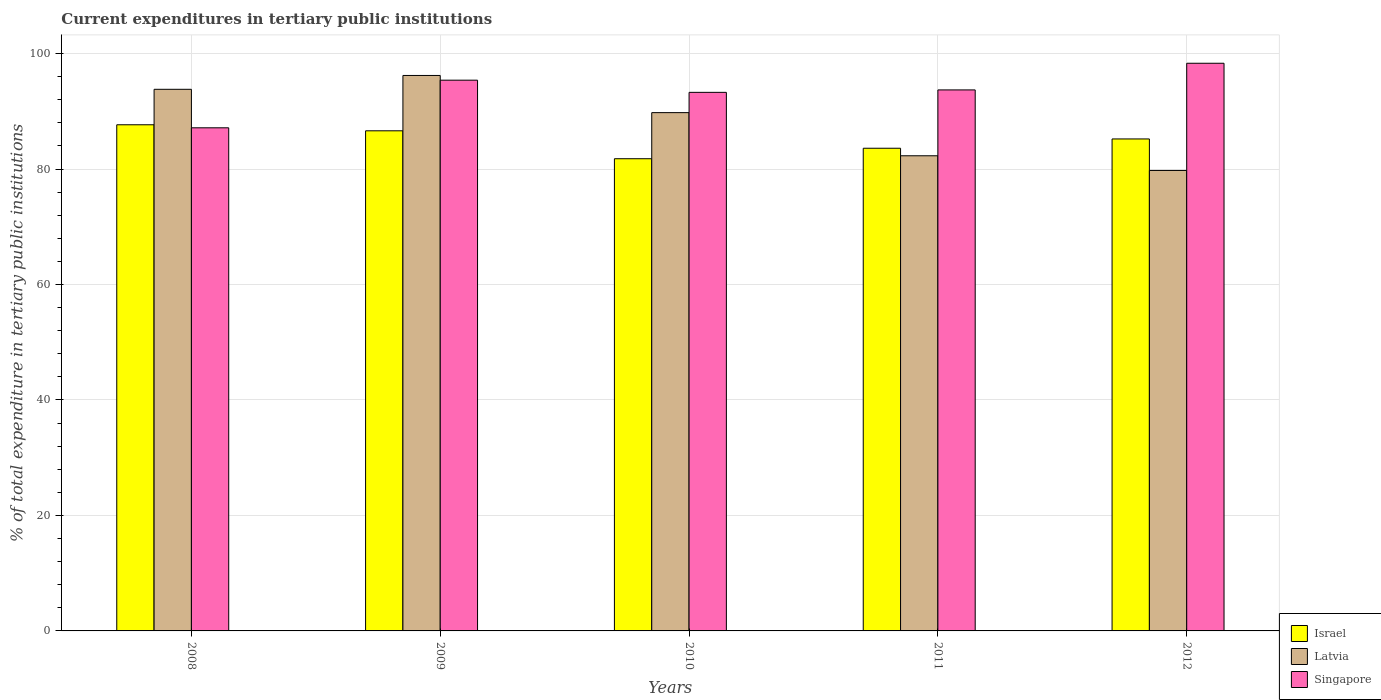How many different coloured bars are there?
Make the answer very short. 3. Are the number of bars per tick equal to the number of legend labels?
Offer a terse response. Yes. How many bars are there on the 2nd tick from the left?
Offer a terse response. 3. What is the label of the 2nd group of bars from the left?
Offer a very short reply. 2009. What is the current expenditures in tertiary public institutions in Latvia in 2010?
Your response must be concise. 89.77. Across all years, what is the maximum current expenditures in tertiary public institutions in Israel?
Ensure brevity in your answer.  87.67. Across all years, what is the minimum current expenditures in tertiary public institutions in Israel?
Your answer should be compact. 81.78. What is the total current expenditures in tertiary public institutions in Israel in the graph?
Ensure brevity in your answer.  424.89. What is the difference between the current expenditures in tertiary public institutions in Singapore in 2008 and that in 2011?
Give a very brief answer. -6.56. What is the difference between the current expenditures in tertiary public institutions in Israel in 2011 and the current expenditures in tertiary public institutions in Singapore in 2012?
Make the answer very short. -14.72. What is the average current expenditures in tertiary public institutions in Latvia per year?
Ensure brevity in your answer.  88.37. In the year 2009, what is the difference between the current expenditures in tertiary public institutions in Latvia and current expenditures in tertiary public institutions in Israel?
Offer a terse response. 9.58. In how many years, is the current expenditures in tertiary public institutions in Latvia greater than 68 %?
Ensure brevity in your answer.  5. What is the ratio of the current expenditures in tertiary public institutions in Singapore in 2009 to that in 2012?
Keep it short and to the point. 0.97. Is the difference between the current expenditures in tertiary public institutions in Latvia in 2008 and 2011 greater than the difference between the current expenditures in tertiary public institutions in Israel in 2008 and 2011?
Your answer should be very brief. Yes. What is the difference between the highest and the second highest current expenditures in tertiary public institutions in Latvia?
Provide a short and direct response. 2.4. What is the difference between the highest and the lowest current expenditures in tertiary public institutions in Singapore?
Offer a terse response. 11.18. In how many years, is the current expenditures in tertiary public institutions in Israel greater than the average current expenditures in tertiary public institutions in Israel taken over all years?
Your response must be concise. 3. Is the sum of the current expenditures in tertiary public institutions in Latvia in 2008 and 2009 greater than the maximum current expenditures in tertiary public institutions in Singapore across all years?
Give a very brief answer. Yes. What does the 2nd bar from the left in 2012 represents?
Offer a terse response. Latvia. What does the 2nd bar from the right in 2008 represents?
Your answer should be compact. Latvia. Is it the case that in every year, the sum of the current expenditures in tertiary public institutions in Israel and current expenditures in tertiary public institutions in Latvia is greater than the current expenditures in tertiary public institutions in Singapore?
Offer a terse response. Yes. How many years are there in the graph?
Your answer should be very brief. 5. What is the difference between two consecutive major ticks on the Y-axis?
Provide a succinct answer. 20. Are the values on the major ticks of Y-axis written in scientific E-notation?
Keep it short and to the point. No. How many legend labels are there?
Keep it short and to the point. 3. What is the title of the graph?
Ensure brevity in your answer.  Current expenditures in tertiary public institutions. What is the label or title of the Y-axis?
Your answer should be very brief. % of total expenditure in tertiary public institutions. What is the % of total expenditure in tertiary public institutions in Israel in 2008?
Your response must be concise. 87.67. What is the % of total expenditure in tertiary public institutions of Latvia in 2008?
Provide a short and direct response. 93.81. What is the % of total expenditure in tertiary public institutions of Singapore in 2008?
Ensure brevity in your answer.  87.14. What is the % of total expenditure in tertiary public institutions of Israel in 2009?
Offer a terse response. 86.62. What is the % of total expenditure in tertiary public institutions of Latvia in 2009?
Your answer should be very brief. 96.21. What is the % of total expenditure in tertiary public institutions in Singapore in 2009?
Ensure brevity in your answer.  95.39. What is the % of total expenditure in tertiary public institutions of Israel in 2010?
Your answer should be very brief. 81.78. What is the % of total expenditure in tertiary public institutions of Latvia in 2010?
Provide a short and direct response. 89.77. What is the % of total expenditure in tertiary public institutions in Singapore in 2010?
Ensure brevity in your answer.  93.28. What is the % of total expenditure in tertiary public institutions of Israel in 2011?
Give a very brief answer. 83.6. What is the % of total expenditure in tertiary public institutions of Latvia in 2011?
Provide a succinct answer. 82.3. What is the % of total expenditure in tertiary public institutions in Singapore in 2011?
Give a very brief answer. 93.7. What is the % of total expenditure in tertiary public institutions in Israel in 2012?
Your answer should be very brief. 85.21. What is the % of total expenditure in tertiary public institutions in Latvia in 2012?
Give a very brief answer. 79.75. What is the % of total expenditure in tertiary public institutions in Singapore in 2012?
Your response must be concise. 98.32. Across all years, what is the maximum % of total expenditure in tertiary public institutions of Israel?
Offer a very short reply. 87.67. Across all years, what is the maximum % of total expenditure in tertiary public institutions in Latvia?
Make the answer very short. 96.21. Across all years, what is the maximum % of total expenditure in tertiary public institutions of Singapore?
Make the answer very short. 98.32. Across all years, what is the minimum % of total expenditure in tertiary public institutions in Israel?
Give a very brief answer. 81.78. Across all years, what is the minimum % of total expenditure in tertiary public institutions in Latvia?
Provide a succinct answer. 79.75. Across all years, what is the minimum % of total expenditure in tertiary public institutions of Singapore?
Give a very brief answer. 87.14. What is the total % of total expenditure in tertiary public institutions of Israel in the graph?
Keep it short and to the point. 424.89. What is the total % of total expenditure in tertiary public institutions of Latvia in the graph?
Your response must be concise. 441.83. What is the total % of total expenditure in tertiary public institutions of Singapore in the graph?
Give a very brief answer. 467.84. What is the difference between the % of total expenditure in tertiary public institutions of Israel in 2008 and that in 2009?
Keep it short and to the point. 1.04. What is the difference between the % of total expenditure in tertiary public institutions in Latvia in 2008 and that in 2009?
Your answer should be compact. -2.4. What is the difference between the % of total expenditure in tertiary public institutions in Singapore in 2008 and that in 2009?
Offer a terse response. -8.25. What is the difference between the % of total expenditure in tertiary public institutions of Israel in 2008 and that in 2010?
Provide a short and direct response. 5.88. What is the difference between the % of total expenditure in tertiary public institutions of Latvia in 2008 and that in 2010?
Provide a succinct answer. 4.04. What is the difference between the % of total expenditure in tertiary public institutions in Singapore in 2008 and that in 2010?
Your answer should be compact. -6.14. What is the difference between the % of total expenditure in tertiary public institutions of Israel in 2008 and that in 2011?
Your response must be concise. 4.07. What is the difference between the % of total expenditure in tertiary public institutions of Latvia in 2008 and that in 2011?
Offer a very short reply. 11.51. What is the difference between the % of total expenditure in tertiary public institutions of Singapore in 2008 and that in 2011?
Keep it short and to the point. -6.56. What is the difference between the % of total expenditure in tertiary public institutions of Israel in 2008 and that in 2012?
Your answer should be compact. 2.46. What is the difference between the % of total expenditure in tertiary public institutions of Latvia in 2008 and that in 2012?
Give a very brief answer. 14.06. What is the difference between the % of total expenditure in tertiary public institutions in Singapore in 2008 and that in 2012?
Ensure brevity in your answer.  -11.18. What is the difference between the % of total expenditure in tertiary public institutions of Israel in 2009 and that in 2010?
Provide a succinct answer. 4.84. What is the difference between the % of total expenditure in tertiary public institutions in Latvia in 2009 and that in 2010?
Offer a terse response. 6.44. What is the difference between the % of total expenditure in tertiary public institutions in Singapore in 2009 and that in 2010?
Offer a terse response. 2.11. What is the difference between the % of total expenditure in tertiary public institutions of Israel in 2009 and that in 2011?
Make the answer very short. 3.02. What is the difference between the % of total expenditure in tertiary public institutions of Latvia in 2009 and that in 2011?
Offer a very short reply. 13.91. What is the difference between the % of total expenditure in tertiary public institutions in Singapore in 2009 and that in 2011?
Offer a very short reply. 1.69. What is the difference between the % of total expenditure in tertiary public institutions in Israel in 2009 and that in 2012?
Offer a very short reply. 1.41. What is the difference between the % of total expenditure in tertiary public institutions of Latvia in 2009 and that in 2012?
Give a very brief answer. 16.45. What is the difference between the % of total expenditure in tertiary public institutions of Singapore in 2009 and that in 2012?
Offer a very short reply. -2.93. What is the difference between the % of total expenditure in tertiary public institutions in Israel in 2010 and that in 2011?
Ensure brevity in your answer.  -1.82. What is the difference between the % of total expenditure in tertiary public institutions of Latvia in 2010 and that in 2011?
Keep it short and to the point. 7.47. What is the difference between the % of total expenditure in tertiary public institutions of Singapore in 2010 and that in 2011?
Make the answer very short. -0.42. What is the difference between the % of total expenditure in tertiary public institutions of Israel in 2010 and that in 2012?
Give a very brief answer. -3.43. What is the difference between the % of total expenditure in tertiary public institutions in Latvia in 2010 and that in 2012?
Your response must be concise. 10.02. What is the difference between the % of total expenditure in tertiary public institutions in Singapore in 2010 and that in 2012?
Provide a short and direct response. -5.04. What is the difference between the % of total expenditure in tertiary public institutions of Israel in 2011 and that in 2012?
Your response must be concise. -1.61. What is the difference between the % of total expenditure in tertiary public institutions of Latvia in 2011 and that in 2012?
Offer a very short reply. 2.54. What is the difference between the % of total expenditure in tertiary public institutions in Singapore in 2011 and that in 2012?
Offer a very short reply. -4.62. What is the difference between the % of total expenditure in tertiary public institutions of Israel in 2008 and the % of total expenditure in tertiary public institutions of Latvia in 2009?
Offer a very short reply. -8.54. What is the difference between the % of total expenditure in tertiary public institutions of Israel in 2008 and the % of total expenditure in tertiary public institutions of Singapore in 2009?
Provide a succinct answer. -7.72. What is the difference between the % of total expenditure in tertiary public institutions in Latvia in 2008 and the % of total expenditure in tertiary public institutions in Singapore in 2009?
Provide a short and direct response. -1.58. What is the difference between the % of total expenditure in tertiary public institutions in Israel in 2008 and the % of total expenditure in tertiary public institutions in Latvia in 2010?
Provide a succinct answer. -2.1. What is the difference between the % of total expenditure in tertiary public institutions of Israel in 2008 and the % of total expenditure in tertiary public institutions of Singapore in 2010?
Your answer should be compact. -5.61. What is the difference between the % of total expenditure in tertiary public institutions of Latvia in 2008 and the % of total expenditure in tertiary public institutions of Singapore in 2010?
Offer a terse response. 0.53. What is the difference between the % of total expenditure in tertiary public institutions in Israel in 2008 and the % of total expenditure in tertiary public institutions in Latvia in 2011?
Offer a very short reply. 5.37. What is the difference between the % of total expenditure in tertiary public institutions in Israel in 2008 and the % of total expenditure in tertiary public institutions in Singapore in 2011?
Offer a very short reply. -6.04. What is the difference between the % of total expenditure in tertiary public institutions in Latvia in 2008 and the % of total expenditure in tertiary public institutions in Singapore in 2011?
Your answer should be compact. 0.11. What is the difference between the % of total expenditure in tertiary public institutions in Israel in 2008 and the % of total expenditure in tertiary public institutions in Latvia in 2012?
Make the answer very short. 7.91. What is the difference between the % of total expenditure in tertiary public institutions in Israel in 2008 and the % of total expenditure in tertiary public institutions in Singapore in 2012?
Offer a very short reply. -10.65. What is the difference between the % of total expenditure in tertiary public institutions of Latvia in 2008 and the % of total expenditure in tertiary public institutions of Singapore in 2012?
Your response must be concise. -4.51. What is the difference between the % of total expenditure in tertiary public institutions of Israel in 2009 and the % of total expenditure in tertiary public institutions of Latvia in 2010?
Your response must be concise. -3.15. What is the difference between the % of total expenditure in tertiary public institutions of Israel in 2009 and the % of total expenditure in tertiary public institutions of Singapore in 2010?
Your answer should be very brief. -6.66. What is the difference between the % of total expenditure in tertiary public institutions in Latvia in 2009 and the % of total expenditure in tertiary public institutions in Singapore in 2010?
Offer a terse response. 2.93. What is the difference between the % of total expenditure in tertiary public institutions of Israel in 2009 and the % of total expenditure in tertiary public institutions of Latvia in 2011?
Your response must be concise. 4.33. What is the difference between the % of total expenditure in tertiary public institutions of Israel in 2009 and the % of total expenditure in tertiary public institutions of Singapore in 2011?
Your answer should be compact. -7.08. What is the difference between the % of total expenditure in tertiary public institutions of Latvia in 2009 and the % of total expenditure in tertiary public institutions of Singapore in 2011?
Ensure brevity in your answer.  2.5. What is the difference between the % of total expenditure in tertiary public institutions in Israel in 2009 and the % of total expenditure in tertiary public institutions in Latvia in 2012?
Provide a short and direct response. 6.87. What is the difference between the % of total expenditure in tertiary public institutions in Israel in 2009 and the % of total expenditure in tertiary public institutions in Singapore in 2012?
Keep it short and to the point. -11.7. What is the difference between the % of total expenditure in tertiary public institutions of Latvia in 2009 and the % of total expenditure in tertiary public institutions of Singapore in 2012?
Keep it short and to the point. -2.11. What is the difference between the % of total expenditure in tertiary public institutions of Israel in 2010 and the % of total expenditure in tertiary public institutions of Latvia in 2011?
Provide a succinct answer. -0.51. What is the difference between the % of total expenditure in tertiary public institutions of Israel in 2010 and the % of total expenditure in tertiary public institutions of Singapore in 2011?
Your answer should be very brief. -11.92. What is the difference between the % of total expenditure in tertiary public institutions of Latvia in 2010 and the % of total expenditure in tertiary public institutions of Singapore in 2011?
Provide a succinct answer. -3.93. What is the difference between the % of total expenditure in tertiary public institutions in Israel in 2010 and the % of total expenditure in tertiary public institutions in Latvia in 2012?
Offer a very short reply. 2.03. What is the difference between the % of total expenditure in tertiary public institutions in Israel in 2010 and the % of total expenditure in tertiary public institutions in Singapore in 2012?
Offer a terse response. -16.54. What is the difference between the % of total expenditure in tertiary public institutions of Latvia in 2010 and the % of total expenditure in tertiary public institutions of Singapore in 2012?
Offer a very short reply. -8.55. What is the difference between the % of total expenditure in tertiary public institutions in Israel in 2011 and the % of total expenditure in tertiary public institutions in Latvia in 2012?
Keep it short and to the point. 3.85. What is the difference between the % of total expenditure in tertiary public institutions of Israel in 2011 and the % of total expenditure in tertiary public institutions of Singapore in 2012?
Give a very brief answer. -14.72. What is the difference between the % of total expenditure in tertiary public institutions in Latvia in 2011 and the % of total expenditure in tertiary public institutions in Singapore in 2012?
Provide a short and direct response. -16.02. What is the average % of total expenditure in tertiary public institutions of Israel per year?
Your answer should be compact. 84.98. What is the average % of total expenditure in tertiary public institutions of Latvia per year?
Give a very brief answer. 88.37. What is the average % of total expenditure in tertiary public institutions of Singapore per year?
Your answer should be compact. 93.57. In the year 2008, what is the difference between the % of total expenditure in tertiary public institutions of Israel and % of total expenditure in tertiary public institutions of Latvia?
Offer a very short reply. -6.14. In the year 2008, what is the difference between the % of total expenditure in tertiary public institutions in Israel and % of total expenditure in tertiary public institutions in Singapore?
Offer a very short reply. 0.53. In the year 2008, what is the difference between the % of total expenditure in tertiary public institutions in Latvia and % of total expenditure in tertiary public institutions in Singapore?
Keep it short and to the point. 6.67. In the year 2009, what is the difference between the % of total expenditure in tertiary public institutions of Israel and % of total expenditure in tertiary public institutions of Latvia?
Make the answer very short. -9.58. In the year 2009, what is the difference between the % of total expenditure in tertiary public institutions of Israel and % of total expenditure in tertiary public institutions of Singapore?
Make the answer very short. -8.77. In the year 2009, what is the difference between the % of total expenditure in tertiary public institutions in Latvia and % of total expenditure in tertiary public institutions in Singapore?
Keep it short and to the point. 0.82. In the year 2010, what is the difference between the % of total expenditure in tertiary public institutions of Israel and % of total expenditure in tertiary public institutions of Latvia?
Provide a short and direct response. -7.99. In the year 2010, what is the difference between the % of total expenditure in tertiary public institutions in Israel and % of total expenditure in tertiary public institutions in Singapore?
Offer a very short reply. -11.5. In the year 2010, what is the difference between the % of total expenditure in tertiary public institutions in Latvia and % of total expenditure in tertiary public institutions in Singapore?
Provide a succinct answer. -3.51. In the year 2011, what is the difference between the % of total expenditure in tertiary public institutions of Israel and % of total expenditure in tertiary public institutions of Latvia?
Give a very brief answer. 1.31. In the year 2011, what is the difference between the % of total expenditure in tertiary public institutions of Israel and % of total expenditure in tertiary public institutions of Singapore?
Ensure brevity in your answer.  -10.1. In the year 2011, what is the difference between the % of total expenditure in tertiary public institutions of Latvia and % of total expenditure in tertiary public institutions of Singapore?
Provide a succinct answer. -11.41. In the year 2012, what is the difference between the % of total expenditure in tertiary public institutions of Israel and % of total expenditure in tertiary public institutions of Latvia?
Your answer should be very brief. 5.46. In the year 2012, what is the difference between the % of total expenditure in tertiary public institutions of Israel and % of total expenditure in tertiary public institutions of Singapore?
Ensure brevity in your answer.  -13.11. In the year 2012, what is the difference between the % of total expenditure in tertiary public institutions of Latvia and % of total expenditure in tertiary public institutions of Singapore?
Your answer should be very brief. -18.57. What is the ratio of the % of total expenditure in tertiary public institutions of Israel in 2008 to that in 2009?
Offer a very short reply. 1.01. What is the ratio of the % of total expenditure in tertiary public institutions of Latvia in 2008 to that in 2009?
Your response must be concise. 0.98. What is the ratio of the % of total expenditure in tertiary public institutions in Singapore in 2008 to that in 2009?
Your response must be concise. 0.91. What is the ratio of the % of total expenditure in tertiary public institutions of Israel in 2008 to that in 2010?
Ensure brevity in your answer.  1.07. What is the ratio of the % of total expenditure in tertiary public institutions in Latvia in 2008 to that in 2010?
Provide a short and direct response. 1.04. What is the ratio of the % of total expenditure in tertiary public institutions in Singapore in 2008 to that in 2010?
Give a very brief answer. 0.93. What is the ratio of the % of total expenditure in tertiary public institutions in Israel in 2008 to that in 2011?
Your response must be concise. 1.05. What is the ratio of the % of total expenditure in tertiary public institutions of Latvia in 2008 to that in 2011?
Offer a very short reply. 1.14. What is the ratio of the % of total expenditure in tertiary public institutions in Israel in 2008 to that in 2012?
Your response must be concise. 1.03. What is the ratio of the % of total expenditure in tertiary public institutions of Latvia in 2008 to that in 2012?
Provide a succinct answer. 1.18. What is the ratio of the % of total expenditure in tertiary public institutions of Singapore in 2008 to that in 2012?
Your answer should be compact. 0.89. What is the ratio of the % of total expenditure in tertiary public institutions of Israel in 2009 to that in 2010?
Provide a short and direct response. 1.06. What is the ratio of the % of total expenditure in tertiary public institutions of Latvia in 2009 to that in 2010?
Provide a succinct answer. 1.07. What is the ratio of the % of total expenditure in tertiary public institutions of Singapore in 2009 to that in 2010?
Provide a short and direct response. 1.02. What is the ratio of the % of total expenditure in tertiary public institutions in Israel in 2009 to that in 2011?
Your answer should be compact. 1.04. What is the ratio of the % of total expenditure in tertiary public institutions of Latvia in 2009 to that in 2011?
Give a very brief answer. 1.17. What is the ratio of the % of total expenditure in tertiary public institutions of Singapore in 2009 to that in 2011?
Make the answer very short. 1.02. What is the ratio of the % of total expenditure in tertiary public institutions in Israel in 2009 to that in 2012?
Make the answer very short. 1.02. What is the ratio of the % of total expenditure in tertiary public institutions in Latvia in 2009 to that in 2012?
Give a very brief answer. 1.21. What is the ratio of the % of total expenditure in tertiary public institutions in Singapore in 2009 to that in 2012?
Provide a short and direct response. 0.97. What is the ratio of the % of total expenditure in tertiary public institutions in Israel in 2010 to that in 2011?
Ensure brevity in your answer.  0.98. What is the ratio of the % of total expenditure in tertiary public institutions of Latvia in 2010 to that in 2011?
Ensure brevity in your answer.  1.09. What is the ratio of the % of total expenditure in tertiary public institutions of Singapore in 2010 to that in 2011?
Offer a terse response. 1. What is the ratio of the % of total expenditure in tertiary public institutions in Israel in 2010 to that in 2012?
Offer a terse response. 0.96. What is the ratio of the % of total expenditure in tertiary public institutions in Latvia in 2010 to that in 2012?
Provide a short and direct response. 1.13. What is the ratio of the % of total expenditure in tertiary public institutions of Singapore in 2010 to that in 2012?
Make the answer very short. 0.95. What is the ratio of the % of total expenditure in tertiary public institutions in Israel in 2011 to that in 2012?
Your answer should be compact. 0.98. What is the ratio of the % of total expenditure in tertiary public institutions of Latvia in 2011 to that in 2012?
Provide a short and direct response. 1.03. What is the ratio of the % of total expenditure in tertiary public institutions in Singapore in 2011 to that in 2012?
Your answer should be very brief. 0.95. What is the difference between the highest and the second highest % of total expenditure in tertiary public institutions in Israel?
Make the answer very short. 1.04. What is the difference between the highest and the second highest % of total expenditure in tertiary public institutions in Latvia?
Your answer should be compact. 2.4. What is the difference between the highest and the second highest % of total expenditure in tertiary public institutions in Singapore?
Ensure brevity in your answer.  2.93. What is the difference between the highest and the lowest % of total expenditure in tertiary public institutions in Israel?
Provide a succinct answer. 5.88. What is the difference between the highest and the lowest % of total expenditure in tertiary public institutions in Latvia?
Your answer should be very brief. 16.45. What is the difference between the highest and the lowest % of total expenditure in tertiary public institutions of Singapore?
Give a very brief answer. 11.18. 